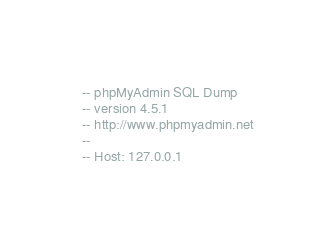Convert code to text. <code><loc_0><loc_0><loc_500><loc_500><_SQL_>-- phpMyAdmin SQL Dump
-- version 4.5.1
-- http://www.phpmyadmin.net
--
-- Host: 127.0.0.1</code> 